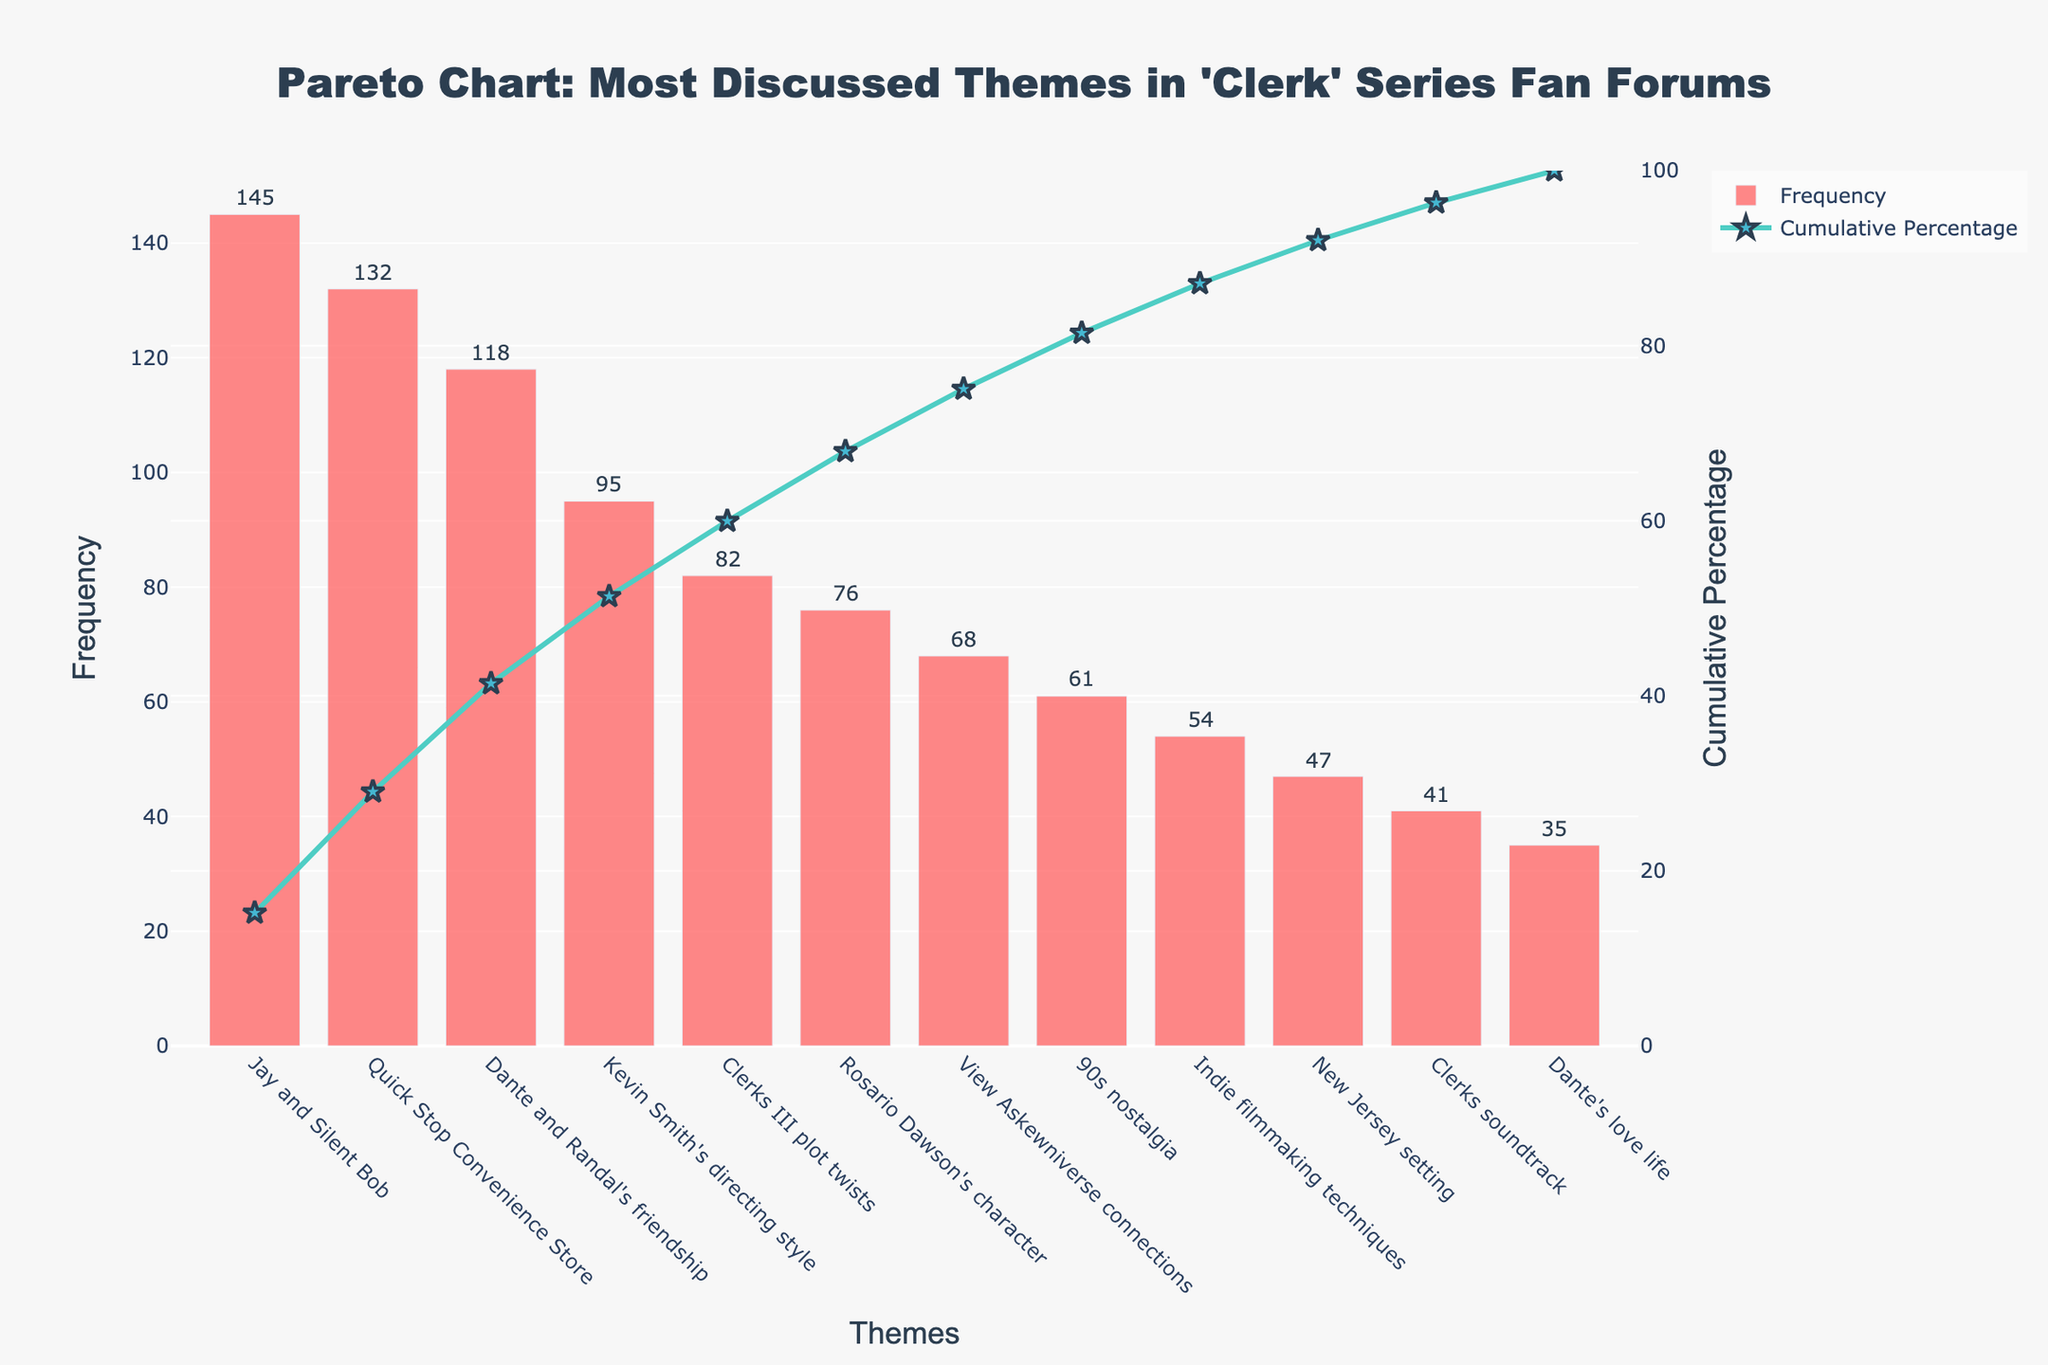What is the most frequently discussed theme in the 'Clerk' series fan forums? The most frequently discussed theme can be identified by looking at the highest bar in the Pareto chart which is "Jay and Silent Bob" with a frequency highest amongst the other themes.
Answer: Jay and Silent Bob What is the cumulative percentage of the top three discussed themes? To find the cumulative percentage of the top three themes, add their frequencies (145 + 132 + 118) and then divide by the total frequency sum (954) before multiplying by 100. The cumulative percentage is shown on the secondary y-axis for "Dante and Randal's friendship."
Answer: 41.31% How much more frequently is "Jay and Silent Bob" discussed compared to "Dante's love life"? Subtract the frequency of "Dante's love life" from "Jay and Silent Bob" (145 - 35).
Answer: 110 Which theme contributes to approximately half of the total discussions alone or cumulatively with other themes? Identify when the cumulative percentage line intersects close to 50% by examining the line overlaid on the bars. "Dante and Randal's friendship" at approximately 41.31% along with "Kevin Smith's directing style" reaches the approximate halfway mark.
Answer: Kevin Smith's directing style What percentage of the discussions is covered by the topics "Clerks III plot twists" and "Rosario Dawson's character" combined? Add the frequencies of both themes (82 + 76), then divide the sum by the total frequency (954) and multiply by 100 to get the percentage.
Answer: 16.57% Between "Quick Stop Convenience Store" and "View Askewniverse connections," which theme has a higher frequency and by how much? The bar for "Quick Stop Convenience Store" is higher than "View Askewniverse connections." Subtract "View Askewniverse connections" frequency from "Quick Stop Convenience Store" (132 - 68).
Answer: Quick Stop Convenience Store, 64 What is the cumulative percentage when we include the top 5 discussed themes? To find the cumulative percentage for the top 5 themes, add their frequencies (145 + 132 + 118 + 95 + 82), divide by the total frequency sum (954), and multiply by 100.
Answer: 72.33% Does the theme "Indie filmmaking techniques" contribute more to discussions than the theme "90s nostalgia"? If so, by what percentage difference? Compare the frequencies of "Indie filmmaking techniques" and "90s nostalgia." Subtract "90s nostalgia" frequency from "Indie filmmaking techniques" frequency and compute the percentage difference: (54 - 61) / 954 * 100.
Answer: No, by −0.73% What is the cumulative percentage of discussions after the 8th most frequently discussed theme? To find the cumulative percentage after the 8th theme, sum up the frequencies up to the 8th theme and examine the cumulative percentage just after the 8th theme, which is "Indie filmmaking techniques."
Answer: After 89.42% What proportion of the total discussions does each of the bottom three themes collectively contribute? Add up the frequencies of the bottom three themes (47 + 41 + 35), divide by the total frequency (954), and multiply by 100.
Answer: 13.20% 